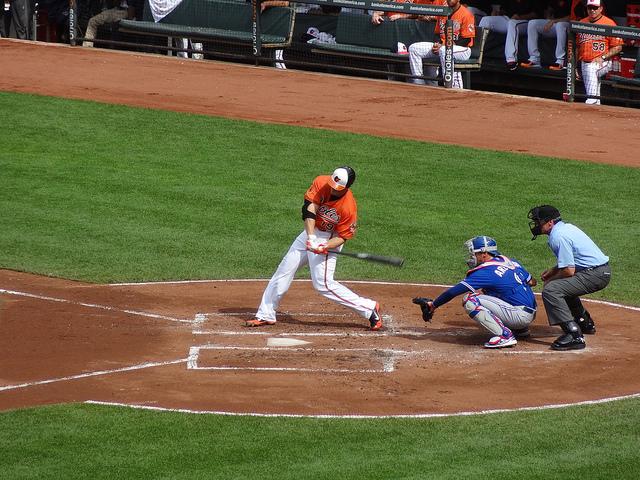What color are the empty seats?
Give a very brief answer. Green. What team is playing?
Write a very short answer. Orioles. What is the item on the bench?
Quick response, please. Towel. How many people are on the field?
Short answer required. 3. What game is this?
Short answer required. Baseball. 